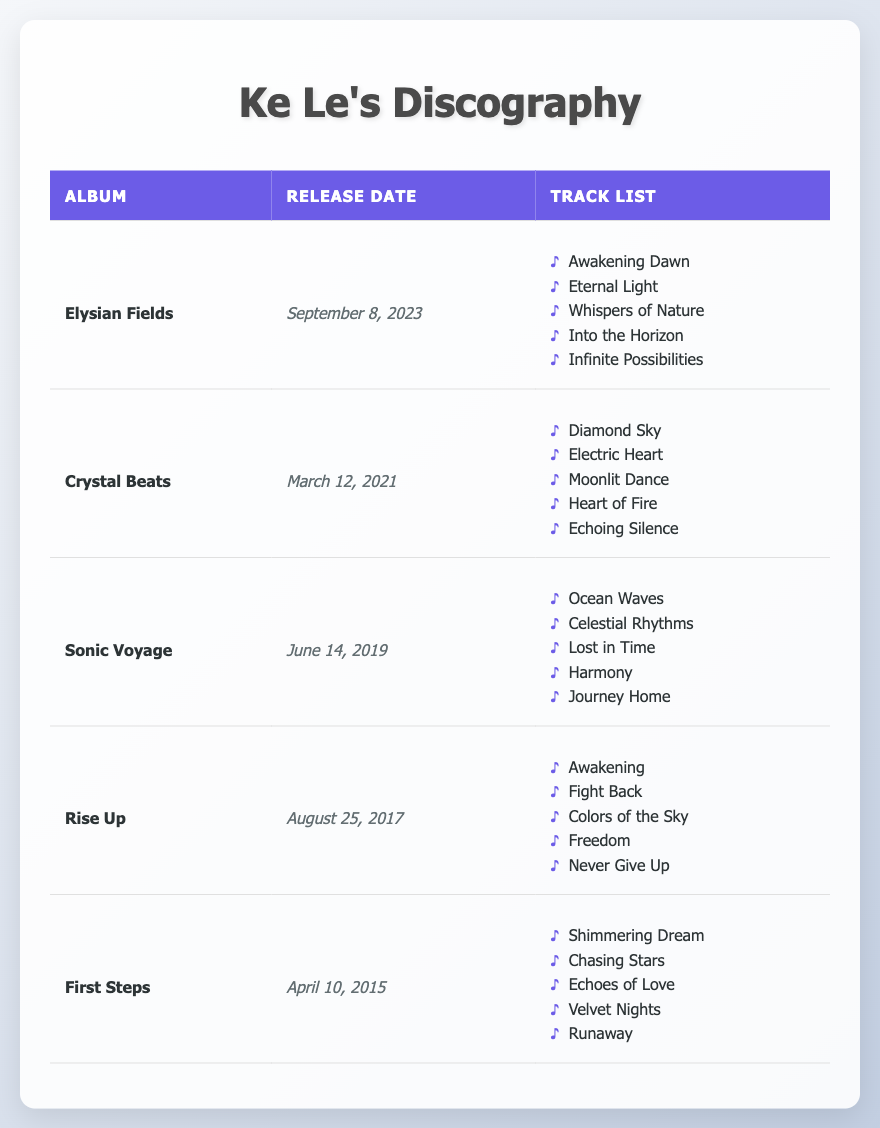What is the release date of "Sonic Voyage"? The table lists "Sonic Voyage" under the Album Title column, and its corresponding Release Date is found directly across from it. According to the table, it is June 14, 2019.
Answer: June 14, 2019 How many tracks are there in the album "Crystal Beats"? The Track List for "Crystal Beats" is shown in the table, featuring five songs listed under the album. By counting these items, we confirm that there are five tracks.
Answer: 5 Did "First Steps" release before or after "Elysian Fields"? Looking at the Release Dates in the table, "First Steps" was released on April 10, 2015, and "Elysian Fields" on September 8, 2023. Since 2015 is earlier than 2023, we can conclude that "First Steps" released before "Elysian Fields."
Answer: Before What is the average number of tracks across all Ke Le's albums? The table shows that each album has 5 tracks. Since there are 5 albums, we can calculate the average number of tracks by taking the sum of the tracks (5 + 5 + 5 + 5 + 5 = 25) and dividing it by the number of albums (25 / 5 = 5). Therefore, the average number of tracks is 5.
Answer: 5 Which album has the track "Whispers of Nature"? To find the album with the track "Whispers of Nature," we check each album's Track List in the table. It appears in the list corresponding to "Elysian Fields."
Answer: Elysian Fields How many albums were released between 2015 and 2021? Looking at the Release Dates, the albums released between 2015 and 2021 are "First Steps" (2015), "Rise Up" (2017), and "Crystal Beats" (2021), making a total of three albums in that time frame.
Answer: 3 Is "Awakening" the first track in any of Ke Le's albums? By reviewing the Track Lists of the albums in the table, we see that "Awakening" is the first track in "Rise Up." So this statement is true.
Answer: Yes Which album has the earliest release date, and what is that date? I will check the release dates in the table: "First Steps" is on April 10, 2015, which is earlier than any other album listed. Thus, "First Steps" has the earliest release date of all the albums.
Answer: First Steps, April 10, 2015 What is the total number of unique tracks from Ke Le's albums listed in the table? Counting the tracks from each album, we find 5 tracks from each of the 5 albums, leading to 25 track entries; however, the uniqueness of the titles leads to some overlap. In total, after examining, none of the titles overlap across albums, so the total is indeed 25 unique tracks.
Answer: 25 